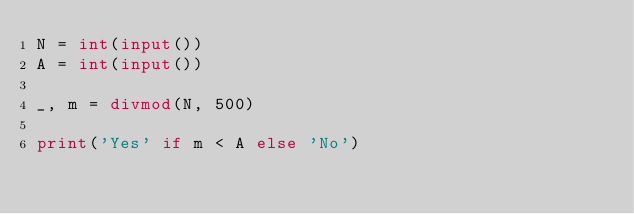Convert code to text. <code><loc_0><loc_0><loc_500><loc_500><_Python_>N = int(input())
A = int(input())

_, m = divmod(N, 500)

print('Yes' if m < A else 'No')</code> 